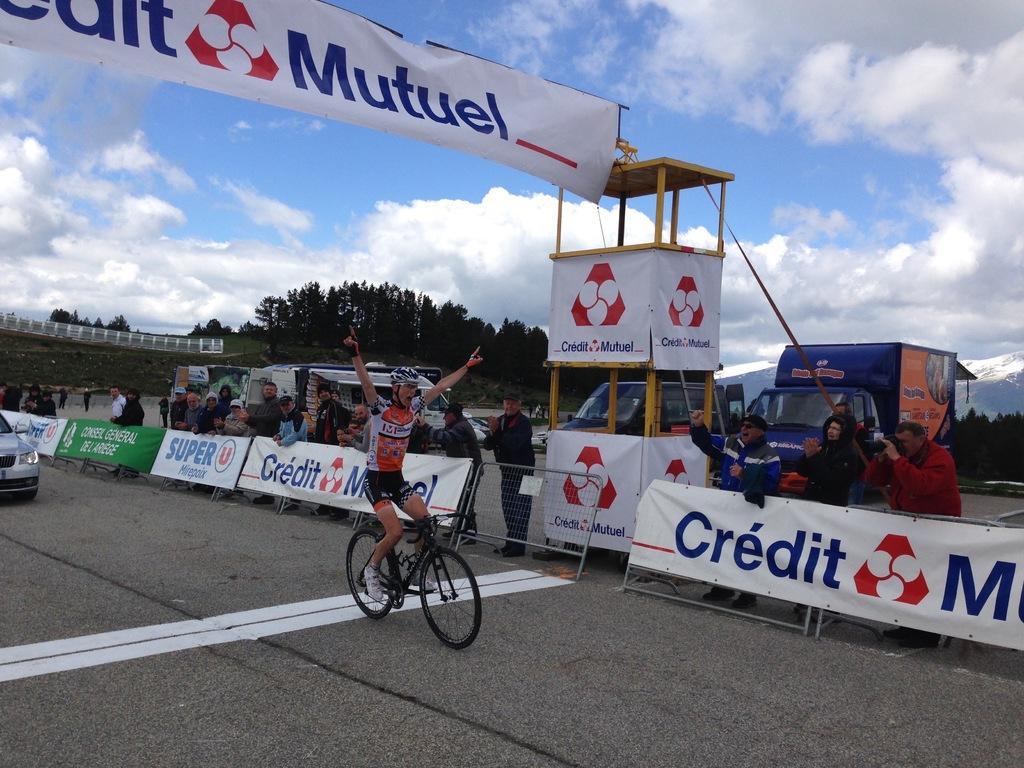How would you summarize this image in a sentence or two? In this image at the bottom there is a road, on which there is a car, bi-cycle, on which there is a person, in the middle there are some vehicles, hoarding boards, on which there is a text, people, stand, at the top there is the sky ,there are some trees visible behind the vehicles. 